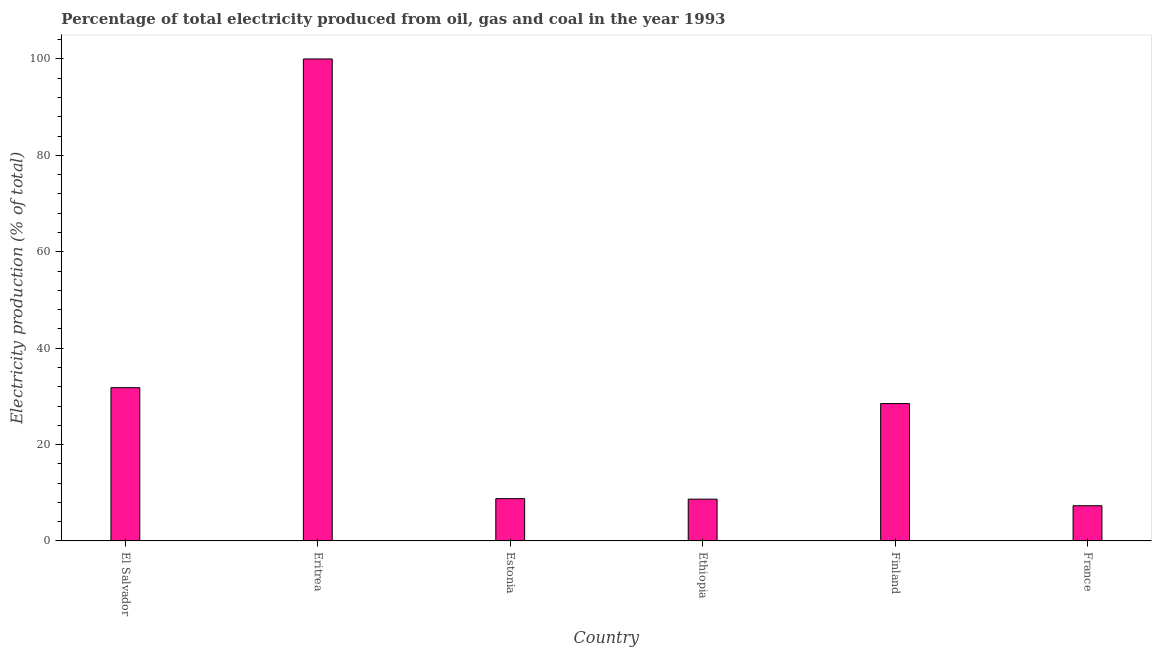Does the graph contain any zero values?
Offer a terse response. No. What is the title of the graph?
Your answer should be very brief. Percentage of total electricity produced from oil, gas and coal in the year 1993. What is the label or title of the X-axis?
Make the answer very short. Country. What is the label or title of the Y-axis?
Provide a short and direct response. Electricity production (% of total). What is the electricity production in France?
Give a very brief answer. 7.31. Across all countries, what is the maximum electricity production?
Keep it short and to the point. 100. Across all countries, what is the minimum electricity production?
Ensure brevity in your answer.  7.31. In which country was the electricity production maximum?
Provide a short and direct response. Eritrea. What is the sum of the electricity production?
Your answer should be compact. 185.08. What is the difference between the electricity production in Estonia and Ethiopia?
Provide a short and direct response. 0.11. What is the average electricity production per country?
Provide a succinct answer. 30.85. What is the median electricity production?
Provide a short and direct response. 18.65. In how many countries, is the electricity production greater than 88 %?
Give a very brief answer. 1. What is the ratio of the electricity production in Ethiopia to that in France?
Your answer should be very brief. 1.19. What is the difference between the highest and the second highest electricity production?
Give a very brief answer. 68.2. What is the difference between the highest and the lowest electricity production?
Offer a very short reply. 92.69. In how many countries, is the electricity production greater than the average electricity production taken over all countries?
Give a very brief answer. 2. Are all the bars in the graph horizontal?
Provide a short and direct response. No. What is the Electricity production (% of total) in El Salvador?
Your answer should be compact. 31.8. What is the Electricity production (% of total) of Estonia?
Your response must be concise. 8.79. What is the Electricity production (% of total) in Ethiopia?
Provide a short and direct response. 8.68. What is the Electricity production (% of total) in Finland?
Your answer should be compact. 28.51. What is the Electricity production (% of total) in France?
Keep it short and to the point. 7.31. What is the difference between the Electricity production (% of total) in El Salvador and Eritrea?
Your answer should be compact. -68.2. What is the difference between the Electricity production (% of total) in El Salvador and Estonia?
Your response must be concise. 23.01. What is the difference between the Electricity production (% of total) in El Salvador and Ethiopia?
Your answer should be very brief. 23.12. What is the difference between the Electricity production (% of total) in El Salvador and Finland?
Your answer should be very brief. 3.29. What is the difference between the Electricity production (% of total) in El Salvador and France?
Your answer should be very brief. 24.49. What is the difference between the Electricity production (% of total) in Eritrea and Estonia?
Your answer should be compact. 91.21. What is the difference between the Electricity production (% of total) in Eritrea and Ethiopia?
Offer a terse response. 91.32. What is the difference between the Electricity production (% of total) in Eritrea and Finland?
Your answer should be compact. 71.49. What is the difference between the Electricity production (% of total) in Eritrea and France?
Provide a short and direct response. 92.69. What is the difference between the Electricity production (% of total) in Estonia and Ethiopia?
Make the answer very short. 0.11. What is the difference between the Electricity production (% of total) in Estonia and Finland?
Provide a short and direct response. -19.72. What is the difference between the Electricity production (% of total) in Estonia and France?
Your answer should be very brief. 1.47. What is the difference between the Electricity production (% of total) in Ethiopia and Finland?
Give a very brief answer. -19.83. What is the difference between the Electricity production (% of total) in Ethiopia and France?
Offer a terse response. 1.37. What is the difference between the Electricity production (% of total) in Finland and France?
Provide a short and direct response. 21.19. What is the ratio of the Electricity production (% of total) in El Salvador to that in Eritrea?
Provide a short and direct response. 0.32. What is the ratio of the Electricity production (% of total) in El Salvador to that in Estonia?
Your answer should be very brief. 3.62. What is the ratio of the Electricity production (% of total) in El Salvador to that in Ethiopia?
Provide a short and direct response. 3.67. What is the ratio of the Electricity production (% of total) in El Salvador to that in Finland?
Your answer should be very brief. 1.12. What is the ratio of the Electricity production (% of total) in El Salvador to that in France?
Keep it short and to the point. 4.35. What is the ratio of the Electricity production (% of total) in Eritrea to that in Estonia?
Make the answer very short. 11.38. What is the ratio of the Electricity production (% of total) in Eritrea to that in Ethiopia?
Provide a succinct answer. 11.53. What is the ratio of the Electricity production (% of total) in Eritrea to that in Finland?
Offer a very short reply. 3.51. What is the ratio of the Electricity production (% of total) in Eritrea to that in France?
Ensure brevity in your answer.  13.68. What is the ratio of the Electricity production (% of total) in Estonia to that in Ethiopia?
Give a very brief answer. 1.01. What is the ratio of the Electricity production (% of total) in Estonia to that in Finland?
Your answer should be very brief. 0.31. What is the ratio of the Electricity production (% of total) in Estonia to that in France?
Keep it short and to the point. 1.2. What is the ratio of the Electricity production (% of total) in Ethiopia to that in Finland?
Your answer should be very brief. 0.3. What is the ratio of the Electricity production (% of total) in Ethiopia to that in France?
Ensure brevity in your answer.  1.19. What is the ratio of the Electricity production (% of total) in Finland to that in France?
Give a very brief answer. 3.9. 